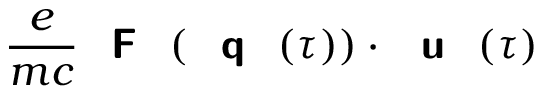Convert formula to latex. <formula><loc_0><loc_0><loc_500><loc_500>\frac { e } { m c } { F } ( { q } ( \tau ) ) \cdot { u } ( \tau )</formula> 